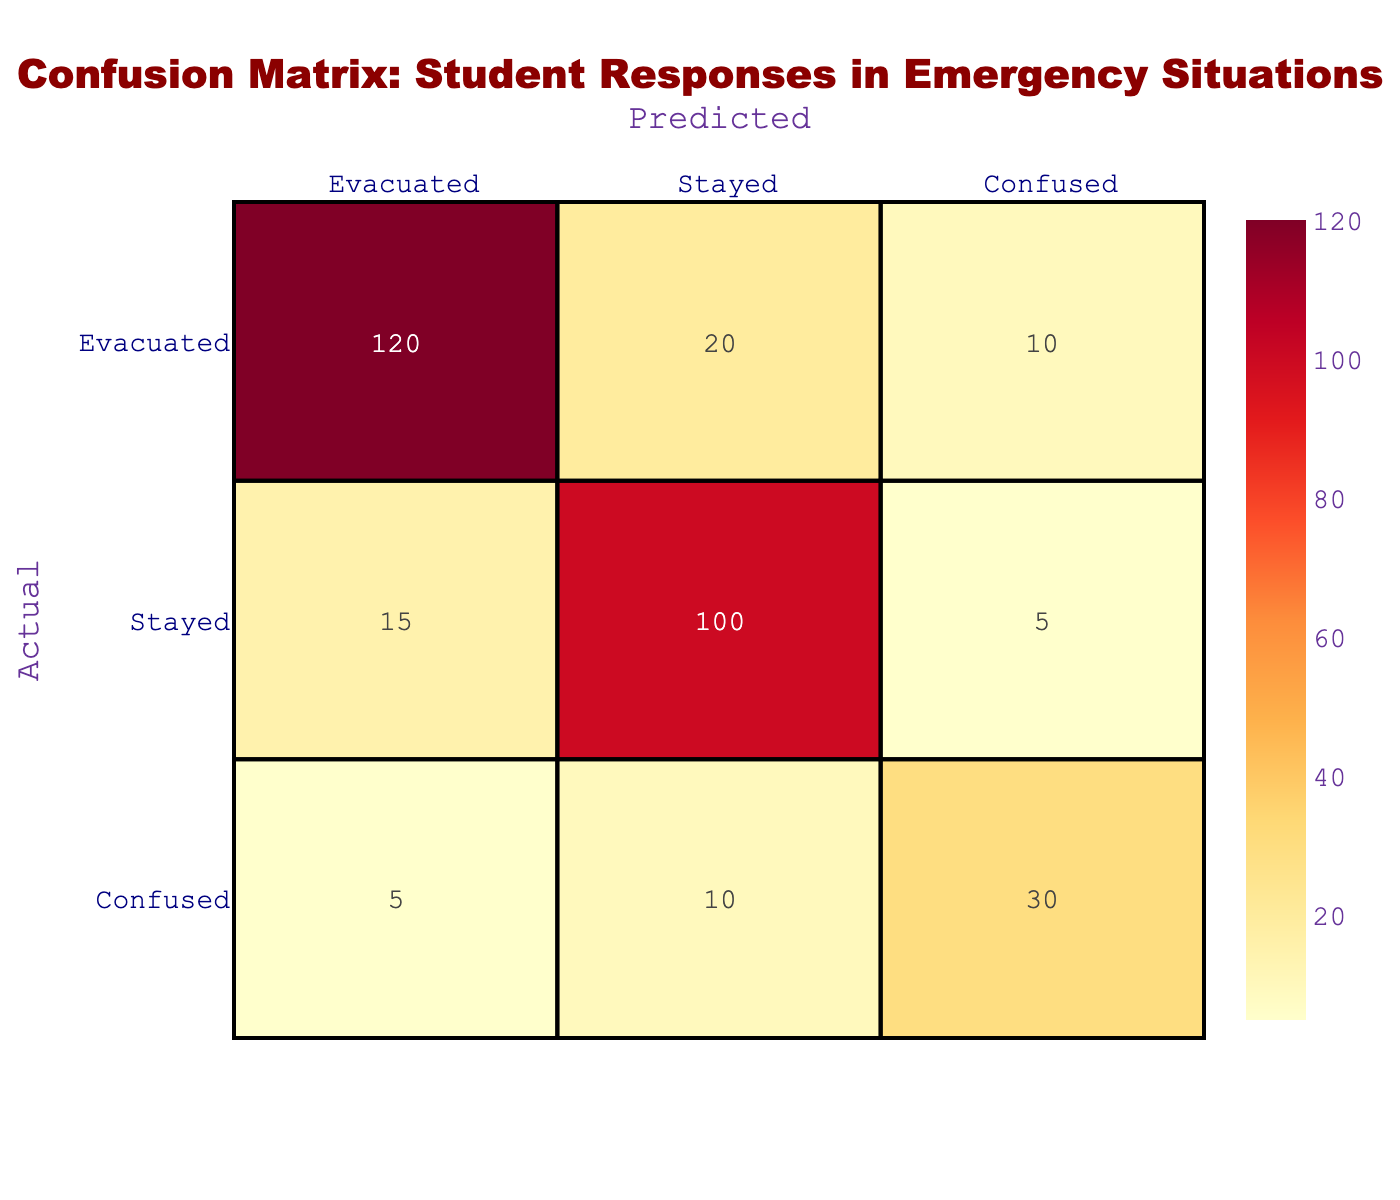What is the total number of students who evacuated? To find the total number of students who evacuated, we look at the "Evacuated" row. Adding the values gives us 120 (correctly evacuated) + 15 (incorrectly stayed) + 5 (incorrectly confused) = 140.
Answer: 140 What percentage of students who were confused actually evacuated? From the "Confused" row, we see that 30 students were actually categorized as confused, and out of these, only 5 students evacuated. To calculate the percentage: (5 / 30) * 100 = 16.67%.
Answer: 16.67% Did more students stay than evacuate? To determine this, we must compare the total number of students who stayed with those who evacuated. The total who stayed is 100 (correctly stayed) + 20 (incorrectly stayed) + 10 (incorrectly confused) = 130. The total who evacuated is 120 (correctly evacuated) + 15 (incorrectly stayed) + 5 (incorrectly confused) = 140. Since 130 < 140, the answer is yes.
Answer: Yes What is the total number of confused students? To find the total number of confused students, we refer to the "Confused" row, which shows 30 students. This is obtained by summing the values in that row directly: 5 (evacuated) + 10 (stayed) + 30 (confused) = 45.
Answer: 45 How many students were correctly categorized as having stayed? Referring to the "Stayed" row, the value under "Stayed" is 100. Therefore, the number of students accurately categorized as stayed is 100.
Answer: 100 What is the overall accuracy rate for evacuating students? To find the accuracy rate for those who evacuated, we first sum the correctly identified evacuations (120) and the correctly identified stays (100) compared to the total responses, which is 120 + 20 + 10 + 15 + 100 + 5 + 5 + 10 + 30 = 315. The accuracy rate is (120 + 100) / 315 = 0.6962, or about 69.62%.
Answer: 69.62% Which group had the highest number of confused responses? Looking at the table, we see the maximum "Confused" entries are 30, shown under the "Confused" row. Therefore, the confused responses are highest in the "Confused" group.
Answer: Confused group What is the total number of students who did not correctly identify their status? Adding the "Incorrect" responses (20 in "Evacuated," 15 in "Stayed," and 10 in "Confused"), we get a total of 20 + 15 + 10 = 45 students.
Answer: 45 